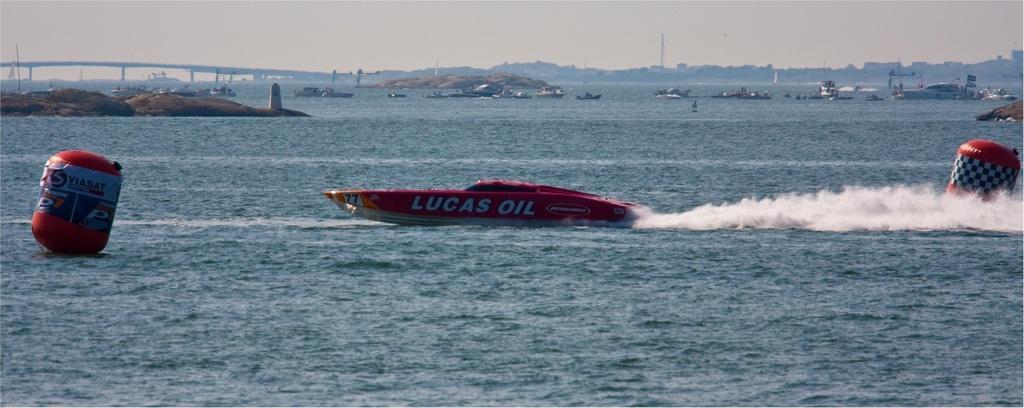In one or two sentences, can you explain what this image depicts? In this image there are a few people sitting in boats, which are floating on the river, there are a few inflatable structures. In the background there is a bridge, mountains and the sky. 